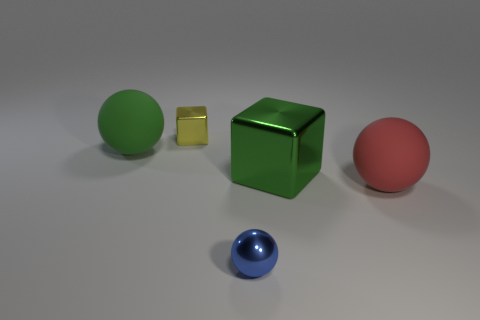Subtract all big spheres. How many spheres are left? 1 Subtract all balls. How many objects are left? 2 Subtract all green spheres. How many spheres are left? 2 Subtract 2 blocks. How many blocks are left? 0 Subtract all red spheres. Subtract all cyan blocks. How many spheres are left? 2 Subtract all cyan cylinders. How many green cubes are left? 1 Subtract all matte objects. Subtract all green metal things. How many objects are left? 2 Add 2 small blue things. How many small blue things are left? 3 Add 3 green matte objects. How many green matte objects exist? 4 Add 3 tiny yellow shiny objects. How many objects exist? 8 